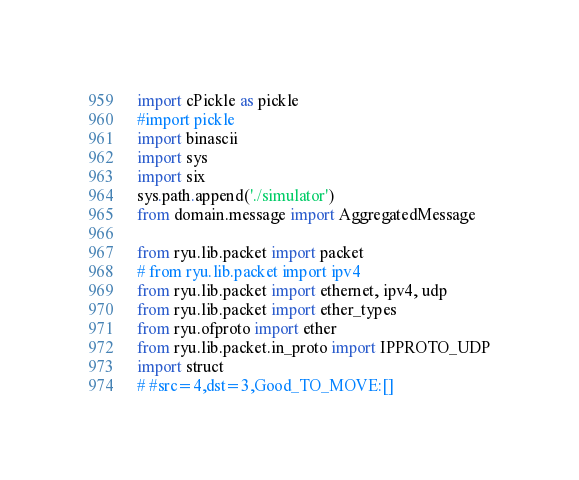Convert code to text. <code><loc_0><loc_0><loc_500><loc_500><_Python_>import cPickle as pickle
#import pickle 
import binascii
import sys
import six
sys.path.append('./simulator')
from domain.message import AggregatedMessage

from ryu.lib.packet import packet
# from ryu.lib.packet import ipv4
from ryu.lib.packet import ethernet, ipv4, udp
from ryu.lib.packet import ether_types
from ryu.ofproto import ether
from ryu.lib.packet.in_proto import IPPROTO_UDP
import struct
# #src=4,dst=3,Good_TO_MOVE:[]</code> 